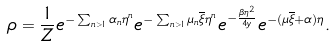Convert formula to latex. <formula><loc_0><loc_0><loc_500><loc_500>\rho = \frac { 1 } { Z } e ^ { - \sum _ { n > 1 } \alpha _ { n } \eta ^ { n } } e ^ { - \sum _ { n > 1 } \mu _ { n } \overline { \xi } \eta ^ { n } } e ^ { - \frac { \beta \eta ^ { 2 } } { 4 y } } e ^ { - ( \mu \overline { \xi } + \alpha ) \eta } .</formula> 